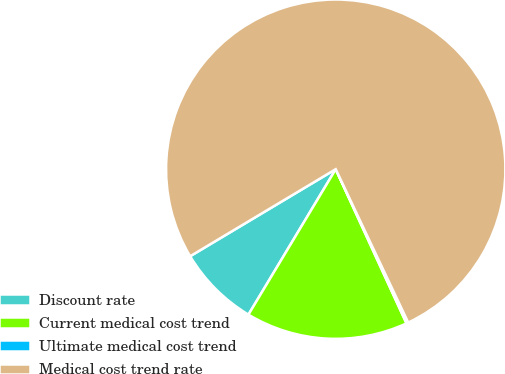Convert chart. <chart><loc_0><loc_0><loc_500><loc_500><pie_chart><fcel>Discount rate<fcel>Current medical cost trend<fcel>Ultimate medical cost trend<fcel>Medical cost trend rate<nl><fcel>7.82%<fcel>15.45%<fcel>0.18%<fcel>76.55%<nl></chart> 